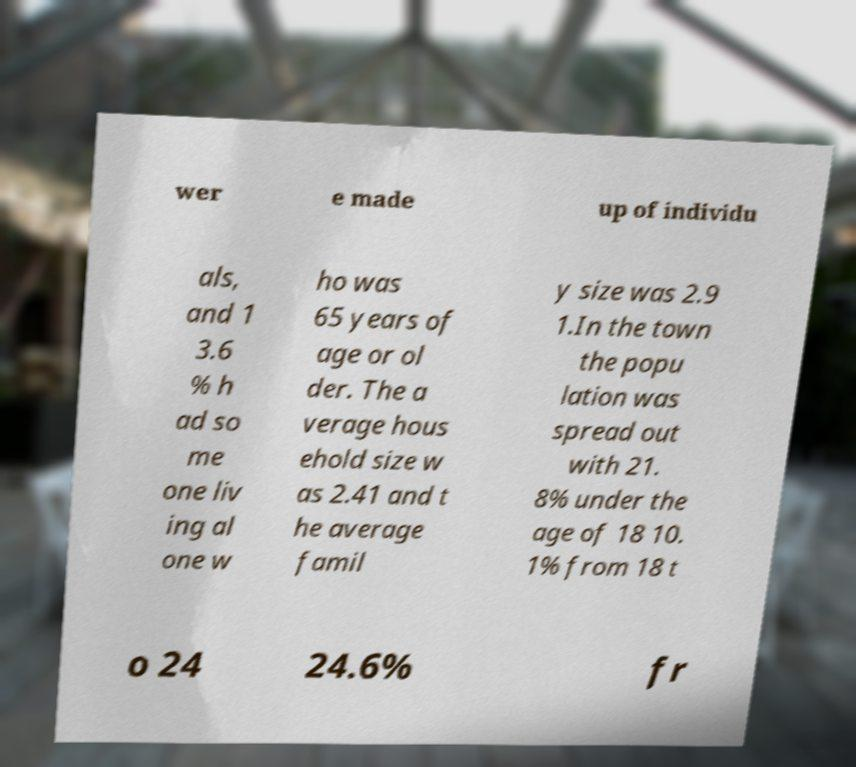I need the written content from this picture converted into text. Can you do that? wer e made up of individu als, and 1 3.6 % h ad so me one liv ing al one w ho was 65 years of age or ol der. The a verage hous ehold size w as 2.41 and t he average famil y size was 2.9 1.In the town the popu lation was spread out with 21. 8% under the age of 18 10. 1% from 18 t o 24 24.6% fr 